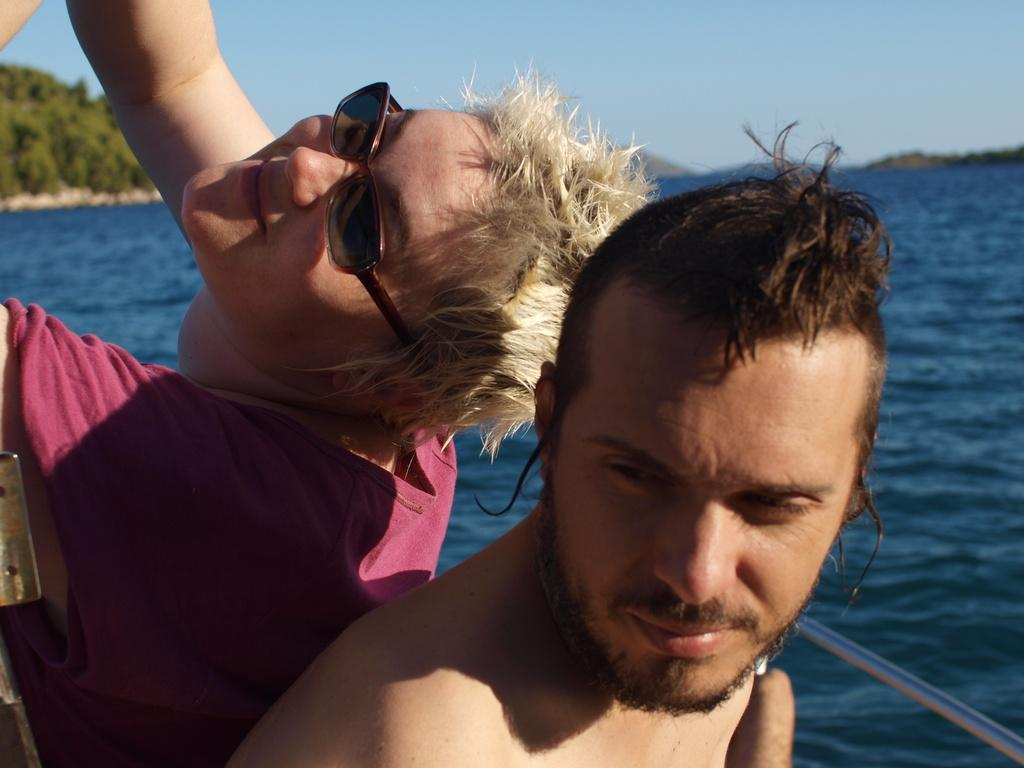What is the main subject of the image? The main subject of the image is persons on a boat. What can be seen in the background of the image? Hills, water, and the sky are visible in the background of the image. What type of chin can be seen on the girl in the image? There is no girl present in the image, only persons on a boat. 